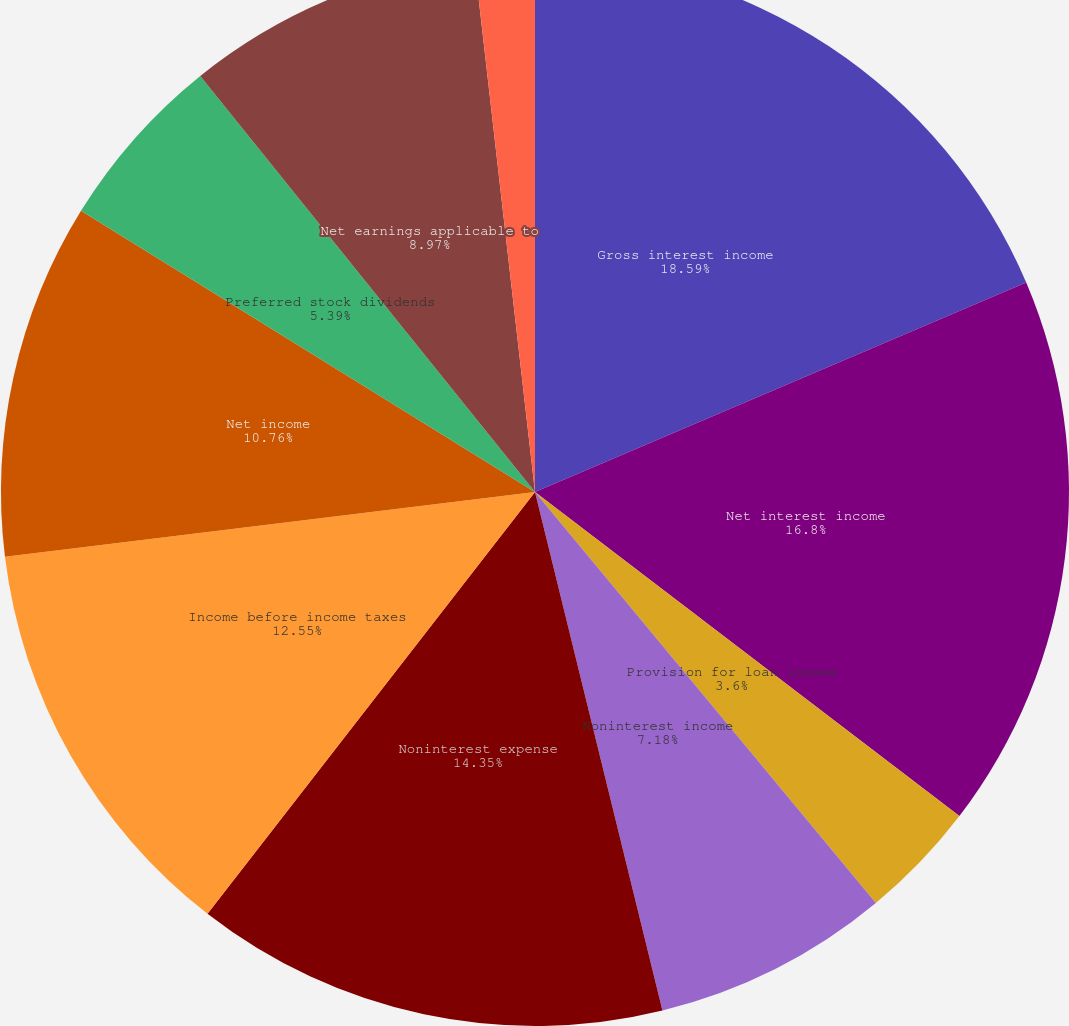Convert chart to OTSL. <chart><loc_0><loc_0><loc_500><loc_500><pie_chart><fcel>Gross interest income<fcel>Net interest income<fcel>Provision for loan losses<fcel>Noninterest income<fcel>Noninterest expense<fcel>Income before income taxes<fcel>Net income<fcel>Preferred stock dividends<fcel>Net earnings applicable to<fcel>Basic<nl><fcel>18.58%<fcel>16.79%<fcel>3.6%<fcel>7.18%<fcel>14.34%<fcel>12.55%<fcel>10.76%<fcel>5.39%<fcel>8.97%<fcel>1.81%<nl></chart> 